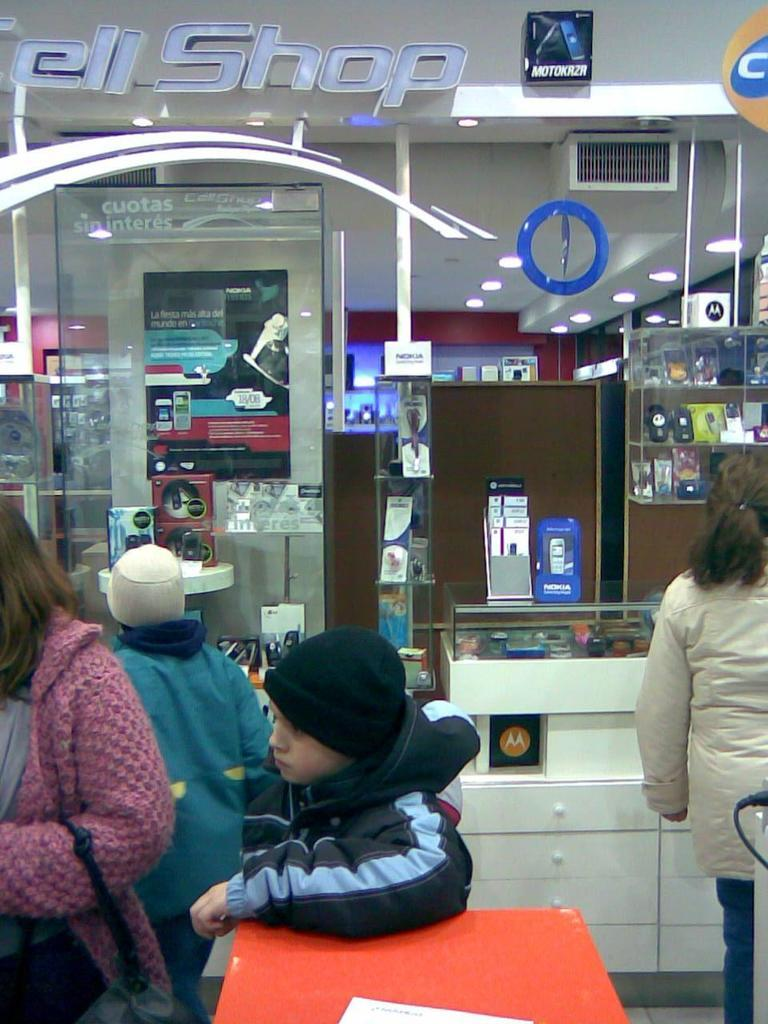<image>
Describe the image concisely. People mill around in front of a store called Cell Shop. 